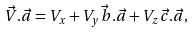Convert formula to latex. <formula><loc_0><loc_0><loc_500><loc_500>\vec { V } . \vec { a } = V _ { x } + V _ { y } \vec { b } . \vec { a } + V _ { z } \vec { c } . \vec { a } ,</formula> 